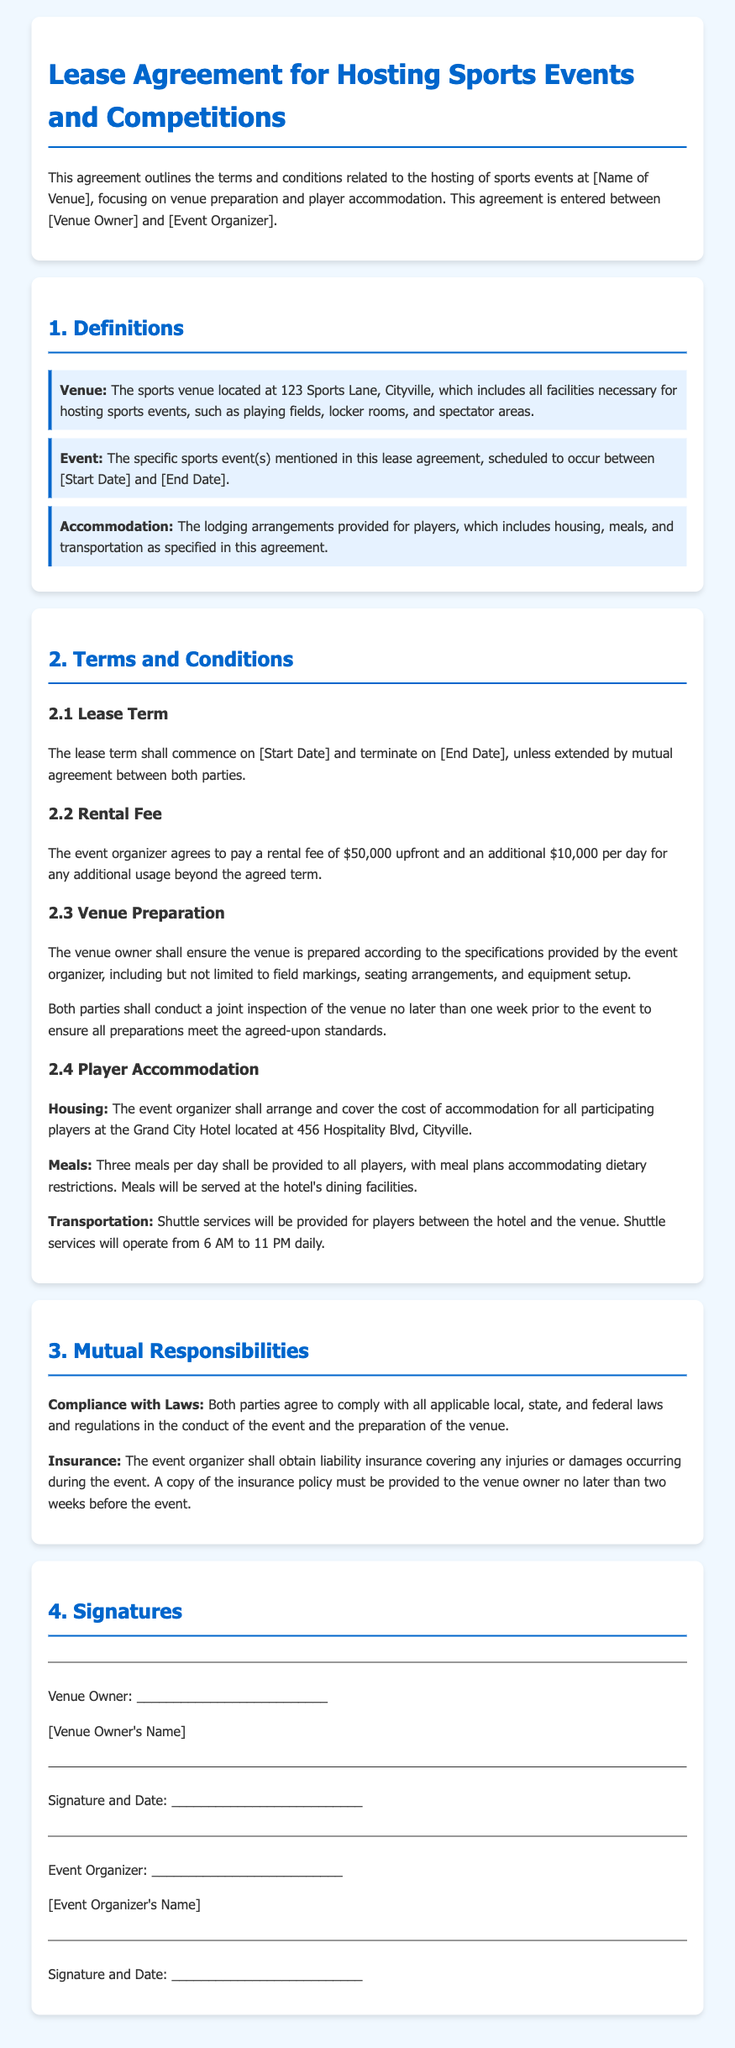What is the venue address? The venue address is specified in the definitions section.
Answer: 123 Sports Lane, Cityville What is the upfront rental fee? The rental fee is clearly stated in the terms and conditions section.
Answer: $50,000 What are the meal provisions for players? The terms related to meals for players are outlined under Player Accommodation.
Answer: Three meals per day When does the lease term commence? The commencement date for the lease term is specified in the terms section.
Answer: [Start Date] What is the latest date for providing the insurance policy? The deadline for providing the insurance policy is mentioned in Mutual Responsibilities.
Answer: Two weeks before the event Who is responsible for player accommodation costs? The responsibility for player accommodation costs is specified in the Player Accommodation section.
Answer: Event Organizer How late will shuttle services operate? The operational hours for shuttle services for players are specified in the Player Accommodation section.
Answer: 11 PM What must both parties comply with? The compliance requirement is addressed in the Mutual Responsibilities section.
Answer: Applicable laws and regulations What is the venue owner's title in the document? The title of the venue owner is mentioned in the Signatures section.
Answer: Venue Owner 